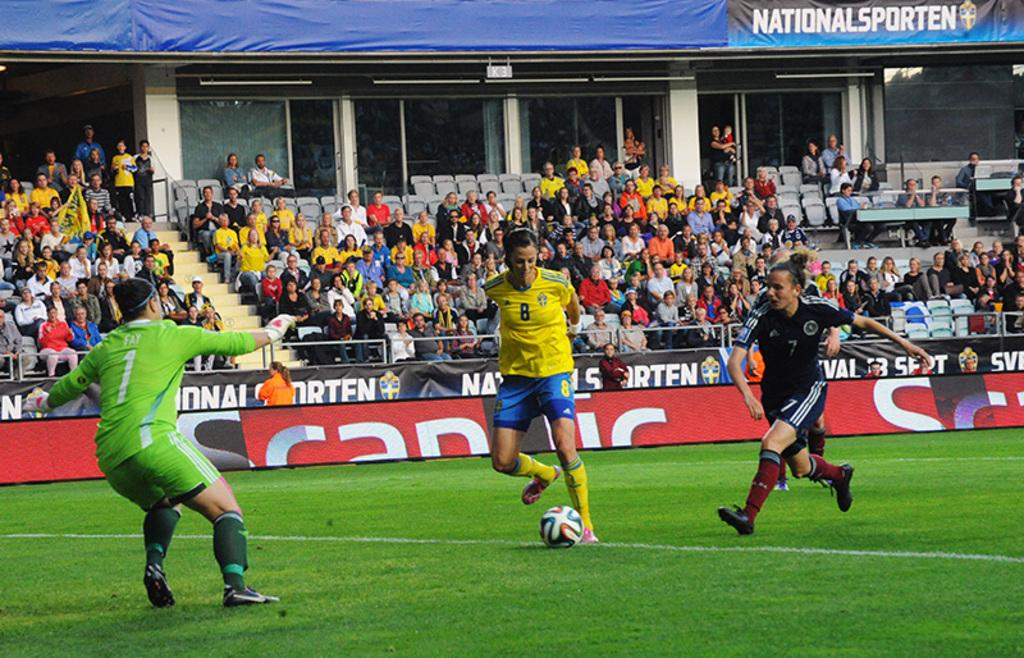Provide a one-sentence caption for the provided image. The player in the green jersey is number 1. 